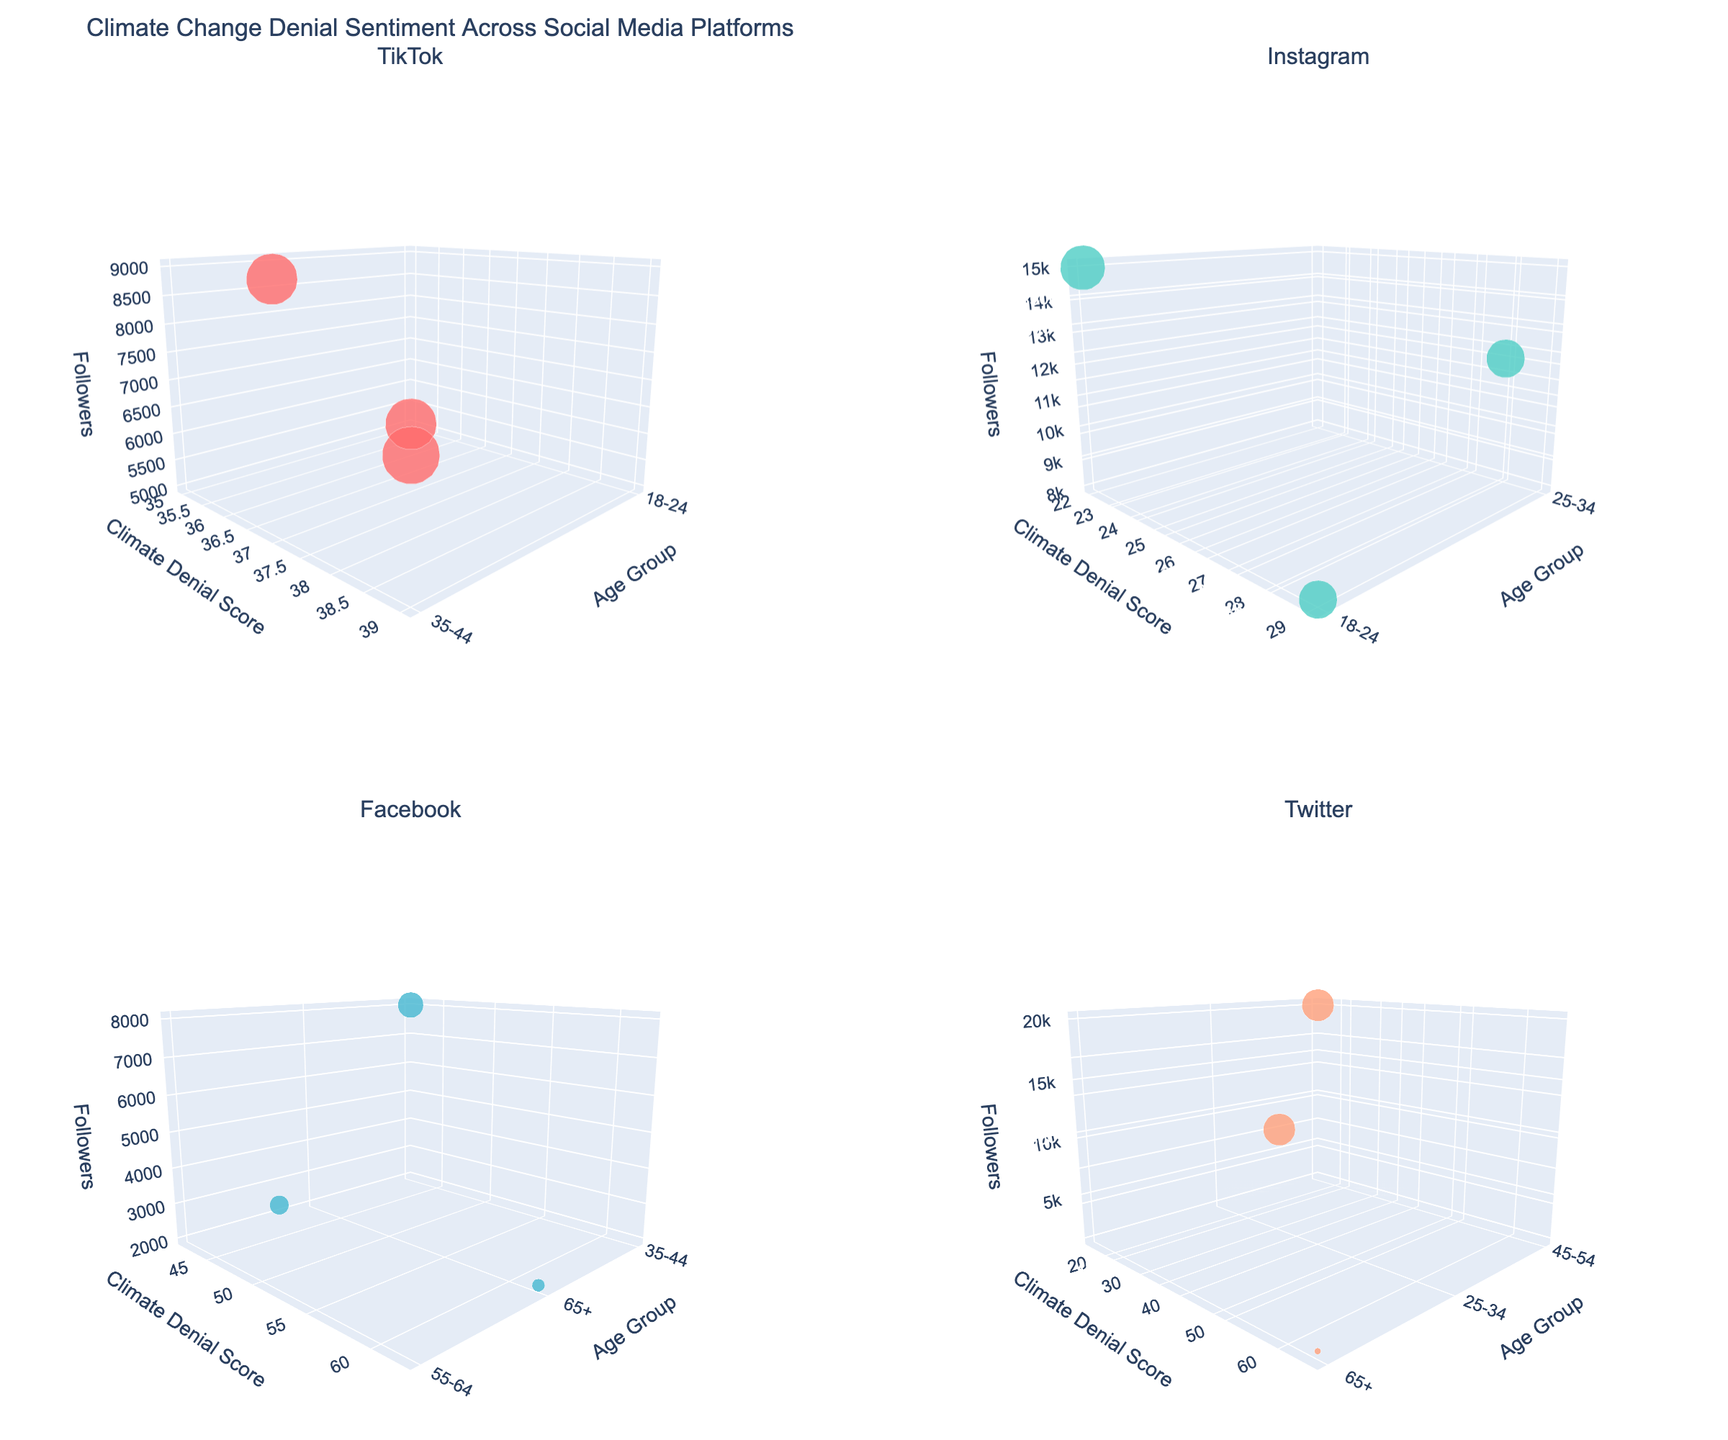What are the age groups represented in the TikTok subplot? The TikTok subplot shows markers at distinct "Age Group" positions on the x-axis. Looking at the x-axis values will tell us the age groups.
Answer: 18-24, 35-44 Which platform shows the highest climate denial score and what is the value? By comparing the y-axis values (Climate Denial Score) across all subplots, the highest point is in the Facebook subplot. The highest score can be pinpointed as 62.
Answer: Facebook, 62 Among the platforms shown, which has the most marked points with PhD education and which age groups do they belong to? By checking the hovering information across PhD marked points on each subplot, the Twitter subplot has markers at age groups '45-54' and '25-34'.
Answer: Twitter, 45-54, 25-34 Which platform has the highest number of followers for users aged 45-54? Inspecting the z-axis (Followers) where the age group is 45-54 across the subplots, the highest number of followers is on YouTube.
Answer: YouTube What is the general trend between age group and engagement rate for TikTok and Instagram? Observing the marker sizes (Engagement Rate) for TikTok and Instagram, we can detect whether engagement rate increases or decreases with age group. In both subplots, larger markers are more common at younger age groups.
Answer: Higher engagement in younger ages Which social media platform has the highest engagement rate for any user? By comparing marker sizes across all subplots, the largest marker is in the TikTok subplot.
Answer: TikTok How do engagement rates for users aged 35-44 compare across different platforms? Checking the sizes of markers at age group 35-44 across all subplots, TikTok and Facebook have relatively larger markers, indicating higher engagement rates.
Answer: Higher on TikTok and Facebook Which platform has the lowest climate denial score for users above the age of 55? By comparing y-axis values (Climate Denial Score) for age groups 55+ in each subplot, Twitter shows the lowest score.
Answer: Twitter 